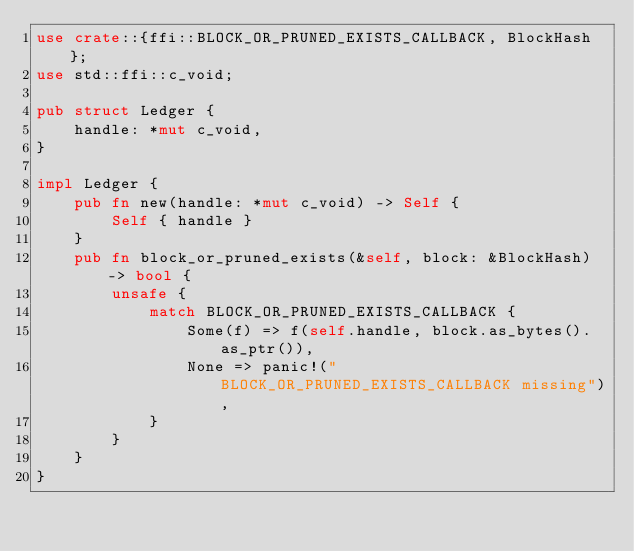<code> <loc_0><loc_0><loc_500><loc_500><_Rust_>use crate::{ffi::BLOCK_OR_PRUNED_EXISTS_CALLBACK, BlockHash};
use std::ffi::c_void;

pub struct Ledger {
    handle: *mut c_void,
}

impl Ledger {
    pub fn new(handle: *mut c_void) -> Self {
        Self { handle }
    }
    pub fn block_or_pruned_exists(&self, block: &BlockHash) -> bool {
        unsafe {
            match BLOCK_OR_PRUNED_EXISTS_CALLBACK {
                Some(f) => f(self.handle, block.as_bytes().as_ptr()),
                None => panic!("BLOCK_OR_PRUNED_EXISTS_CALLBACK missing"),
            }
        }
    }
}
</code> 